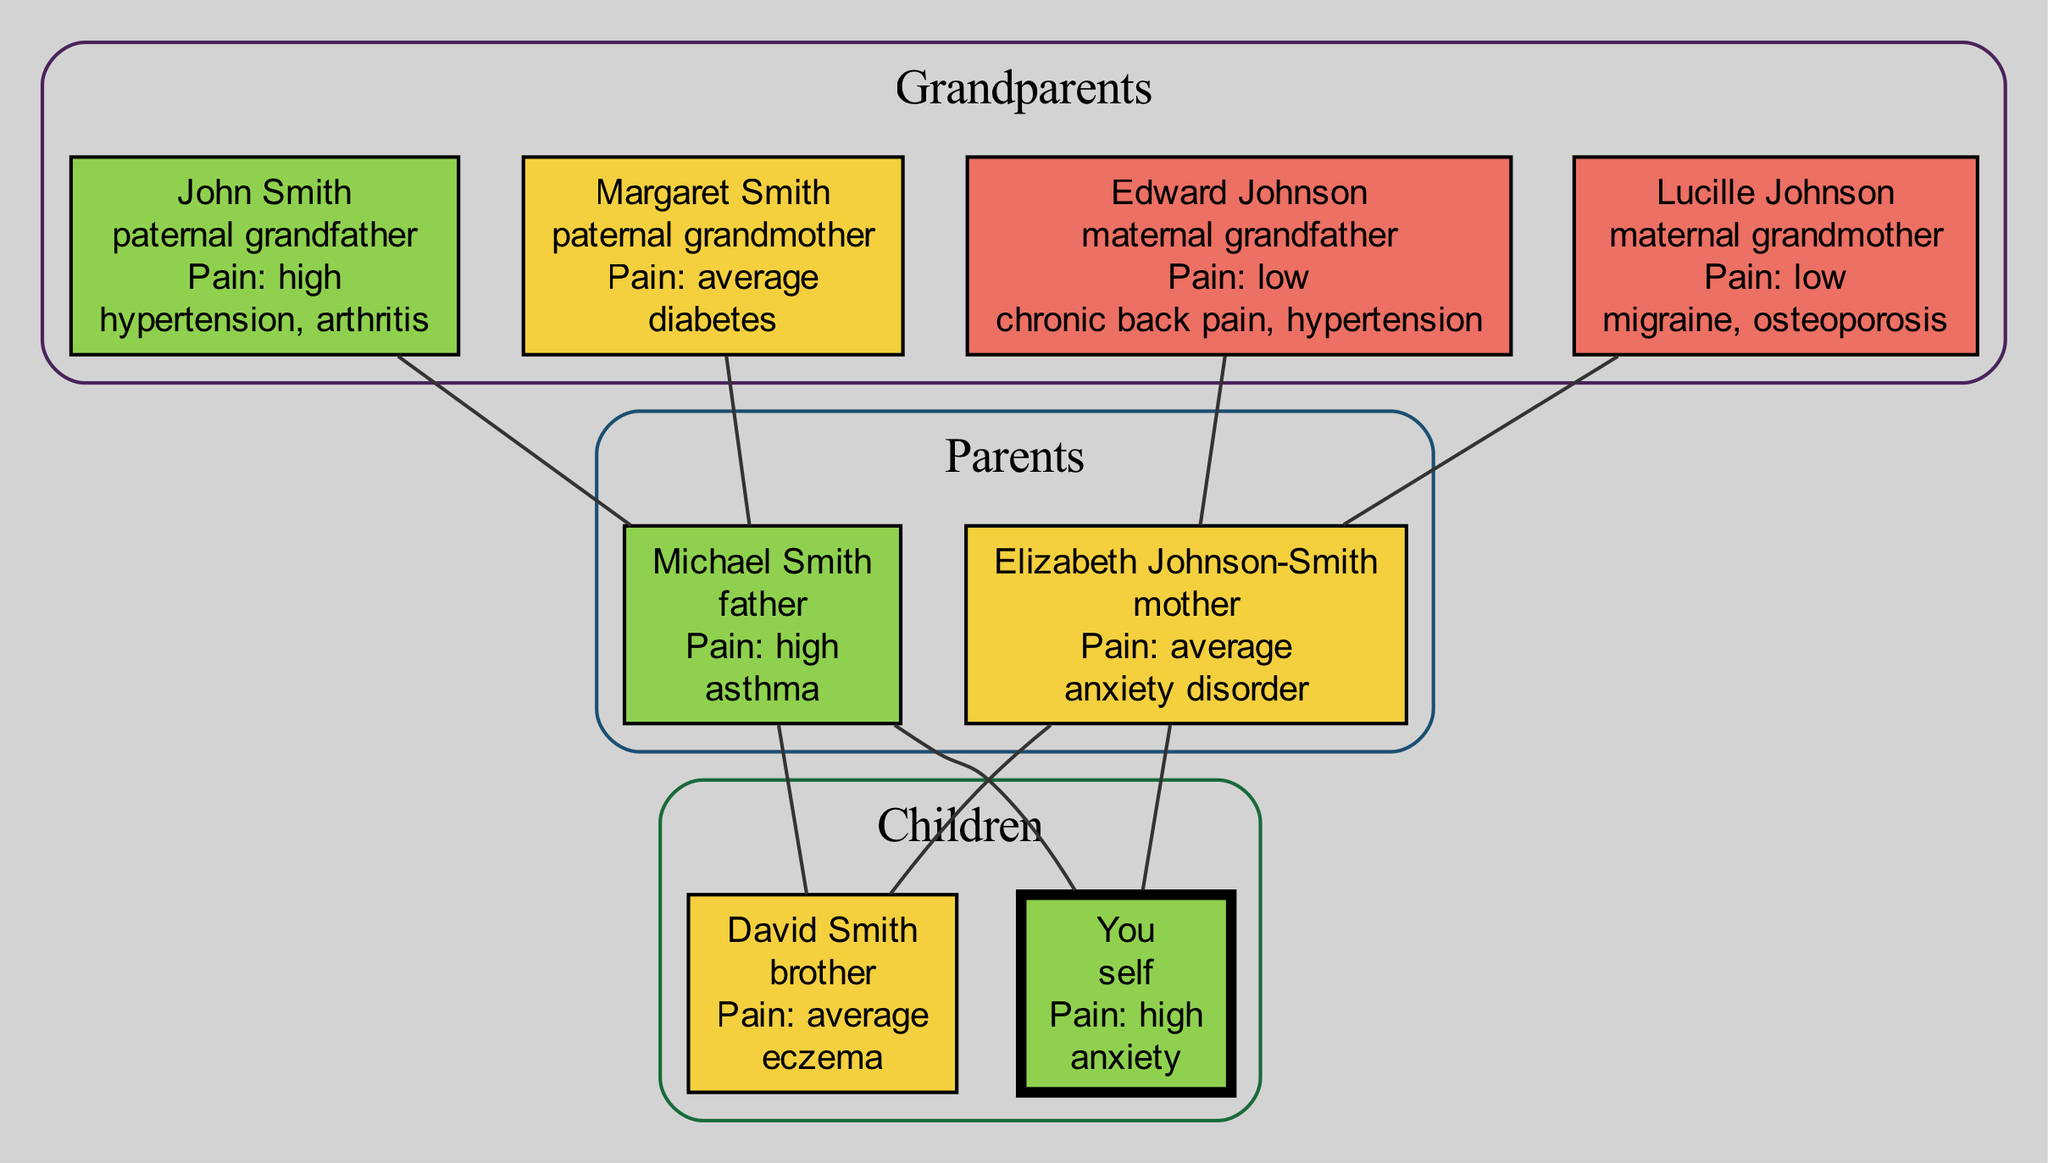What is the pain tolerance level of John Smith? John Smith is identified in the family tree as the paternal grandfather. His pain tolerance level is explicitly stated as 'high' in the diagram section detailing his information.
Answer: high How many grandparents have a low pain tolerance? In the diagram, two grandparents are noted to have a low pain tolerance: Edward Johnson, the maternal grandfather, and Lucille Johnson, the maternal grandmother. Therefore, by counting these names, we determine the total.
Answer: 2 Which family member has an average pain tolerance and suffers from eczema? David Smith, the brother, is the family member with an average pain tolerance. The diagram shows alongside his name that he has the health condition of eczema.
Answer: David Smith What health condition does Michael Smith have? According to the diagram, Michael Smith, the father, is listed with having asthma as his known health condition. This information can be found in the section of the diagram where his details are outlined.
Answer: asthma Who are the parents of David Smith? The diagram illustrates that David Smith shares his parents with 'You', who are identified as Michael Smith and Elizabeth Johnson-Smith. Trace the connections in the diagram to confirm this relationship.
Answer: Michael Smith and Elizabeth Johnson-Smith How many family members have a high pain tolerance? There are three family members noted in the diagram with a high pain tolerance: John Smith (paternal grandfather), Michael Smith (father), and 'You' (self). We can count these individuals directly from their respective sections in the diagram.
Answer: 3 Which relative has both high pain tolerance and a health condition of anxiety? The diagram clearly indicates that 'You' are the only relative who has a high pain tolerance level and suffers from the health condition of anxiety. This information is directly referenced next to your name in the self-section.
Answer: You Which health condition is associated with the maternal grandmother? Lucille Johnson, the maternal grandmother, has been documented to have migraine and osteoporosis as her health conditions. This information is specifically laid out in her details section in the diagram.
Answer: migraine and osteoporosis Who is the only family member with anxiety disorder? The diagram lists Elizabeth Johnson-Smith, the mother, as having an anxiety disorder. This information is plainly available in the health conditions part of her profile.
Answer: Elizabeth Johnson-Smith 